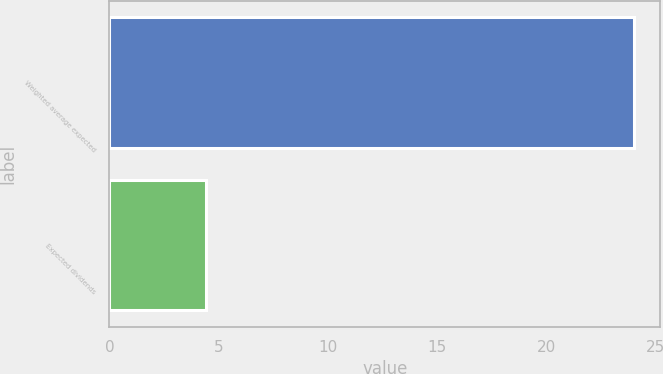<chart> <loc_0><loc_0><loc_500><loc_500><bar_chart><fcel>Weighted average expected<fcel>Expected dividends<nl><fcel>24<fcel>4.43<nl></chart> 